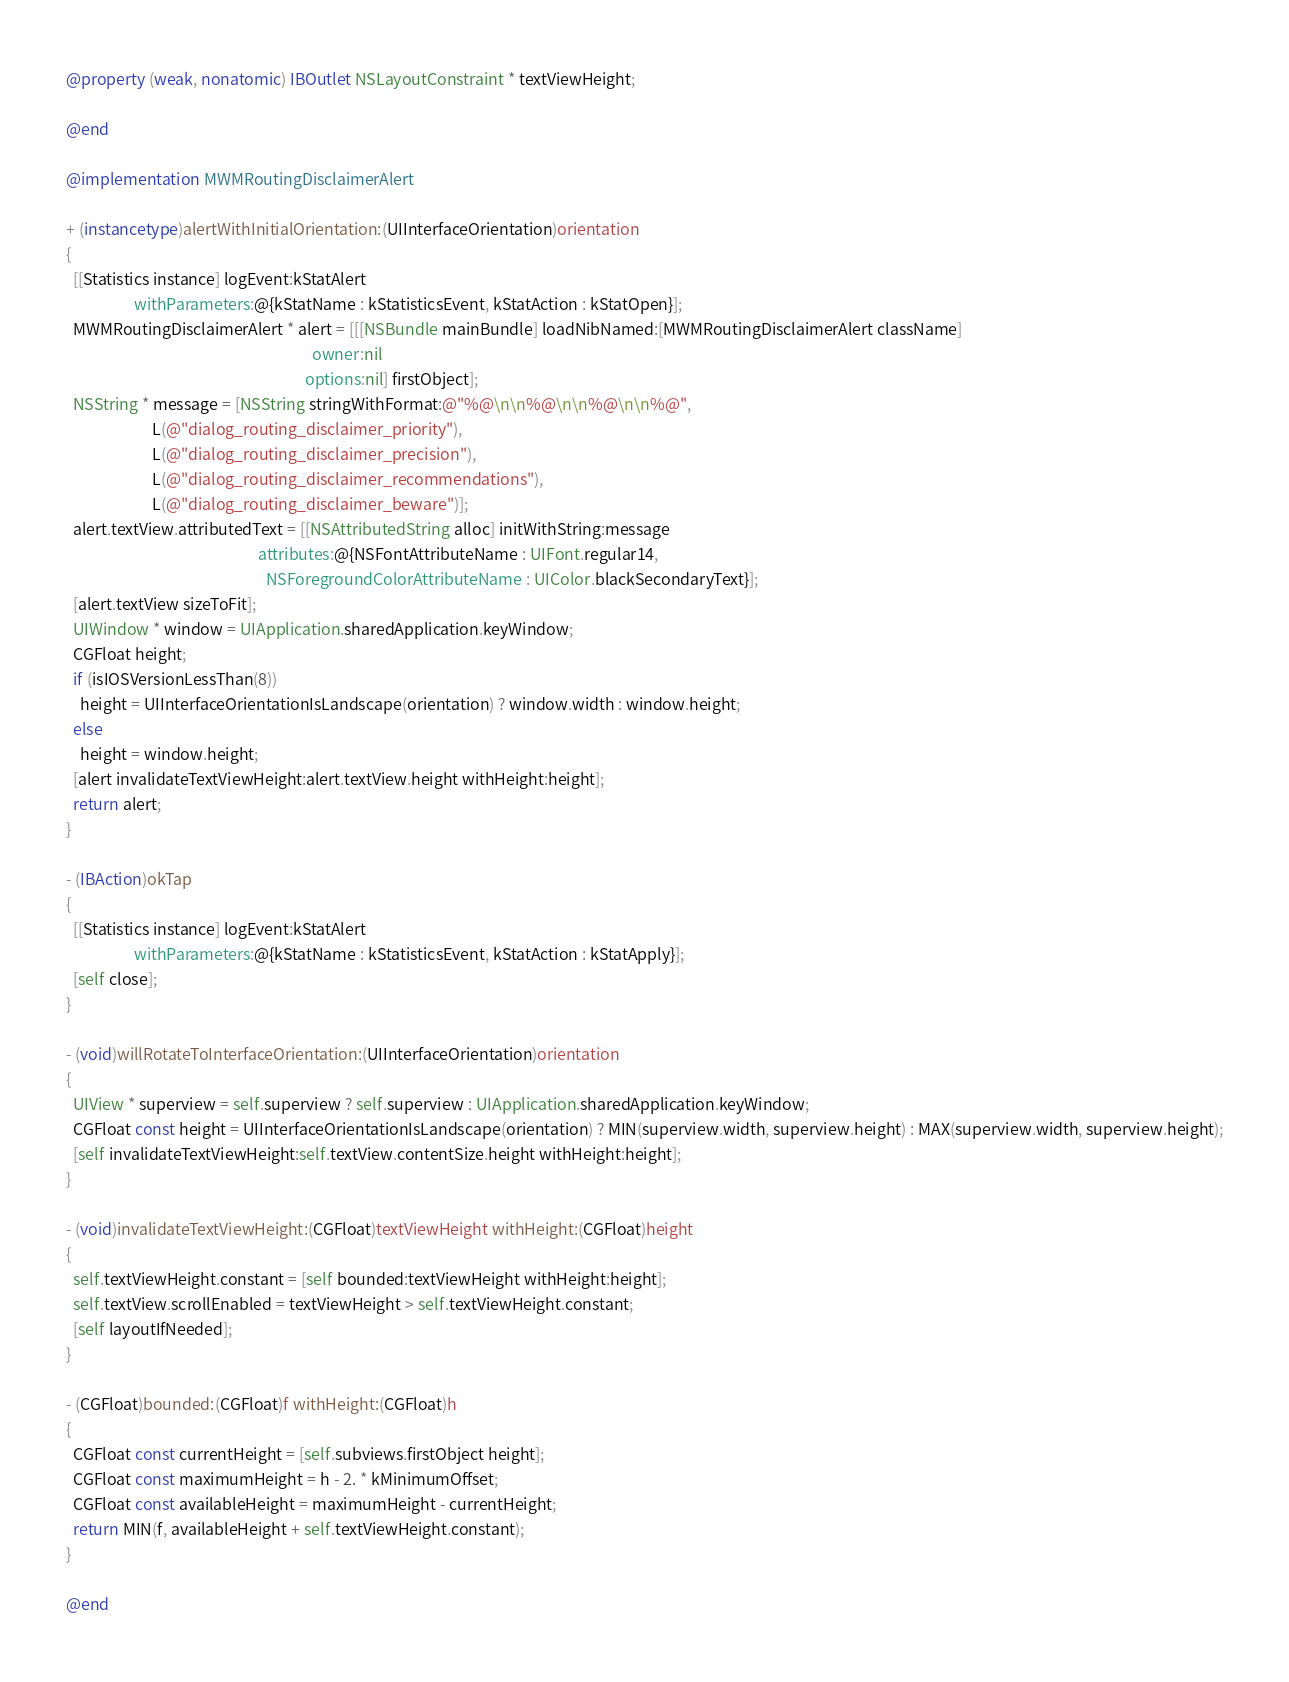<code> <loc_0><loc_0><loc_500><loc_500><_ObjectiveC_>@property (weak, nonatomic) IBOutlet NSLayoutConstraint * textViewHeight;

@end

@implementation MWMRoutingDisclaimerAlert

+ (instancetype)alertWithInitialOrientation:(UIInterfaceOrientation)orientation
{
  [[Statistics instance] logEvent:kStatAlert
                   withParameters:@{kStatName : kStatisticsEvent, kStatAction : kStatOpen}];
  MWMRoutingDisclaimerAlert * alert = [[[NSBundle mainBundle] loadNibNamed:[MWMRoutingDisclaimerAlert className]
                                                                     owner:nil
                                                                   options:nil] firstObject];
  NSString * message = [NSString stringWithFormat:@"%@\n\n%@\n\n%@\n\n%@",
                        L(@"dialog_routing_disclaimer_priority"),
                        L(@"dialog_routing_disclaimer_precision"),
                        L(@"dialog_routing_disclaimer_recommendations"),
                        L(@"dialog_routing_disclaimer_beware")];
  alert.textView.attributedText = [[NSAttributedString alloc] initWithString:message
                                                      attributes:@{NSFontAttributeName : UIFont.regular14,
                                                        NSForegroundColorAttributeName : UIColor.blackSecondaryText}];
  [alert.textView sizeToFit];
  UIWindow * window = UIApplication.sharedApplication.keyWindow;
  CGFloat height;
  if (isIOSVersionLessThan(8))
    height = UIInterfaceOrientationIsLandscape(orientation) ? window.width : window.height;
  else
    height = window.height;
  [alert invalidateTextViewHeight:alert.textView.height withHeight:height];
  return alert;
}

- (IBAction)okTap
{
  [[Statistics instance] logEvent:kStatAlert
                   withParameters:@{kStatName : kStatisticsEvent, kStatAction : kStatApply}];
  [self close];
}

- (void)willRotateToInterfaceOrientation:(UIInterfaceOrientation)orientation
{
  UIView * superview = self.superview ? self.superview : UIApplication.sharedApplication.keyWindow;
  CGFloat const height = UIInterfaceOrientationIsLandscape(orientation) ? MIN(superview.width, superview.height) : MAX(superview.width, superview.height);
  [self invalidateTextViewHeight:self.textView.contentSize.height withHeight:height];
}

- (void)invalidateTextViewHeight:(CGFloat)textViewHeight withHeight:(CGFloat)height
{
  self.textViewHeight.constant = [self bounded:textViewHeight withHeight:height];
  self.textView.scrollEnabled = textViewHeight > self.textViewHeight.constant;
  [self layoutIfNeeded];
}

- (CGFloat)bounded:(CGFloat)f withHeight:(CGFloat)h
{
  CGFloat const currentHeight = [self.subviews.firstObject height];
  CGFloat const maximumHeight = h - 2. * kMinimumOffset;
  CGFloat const availableHeight = maximumHeight - currentHeight;
  return MIN(f, availableHeight + self.textViewHeight.constant);
}

@end
</code> 